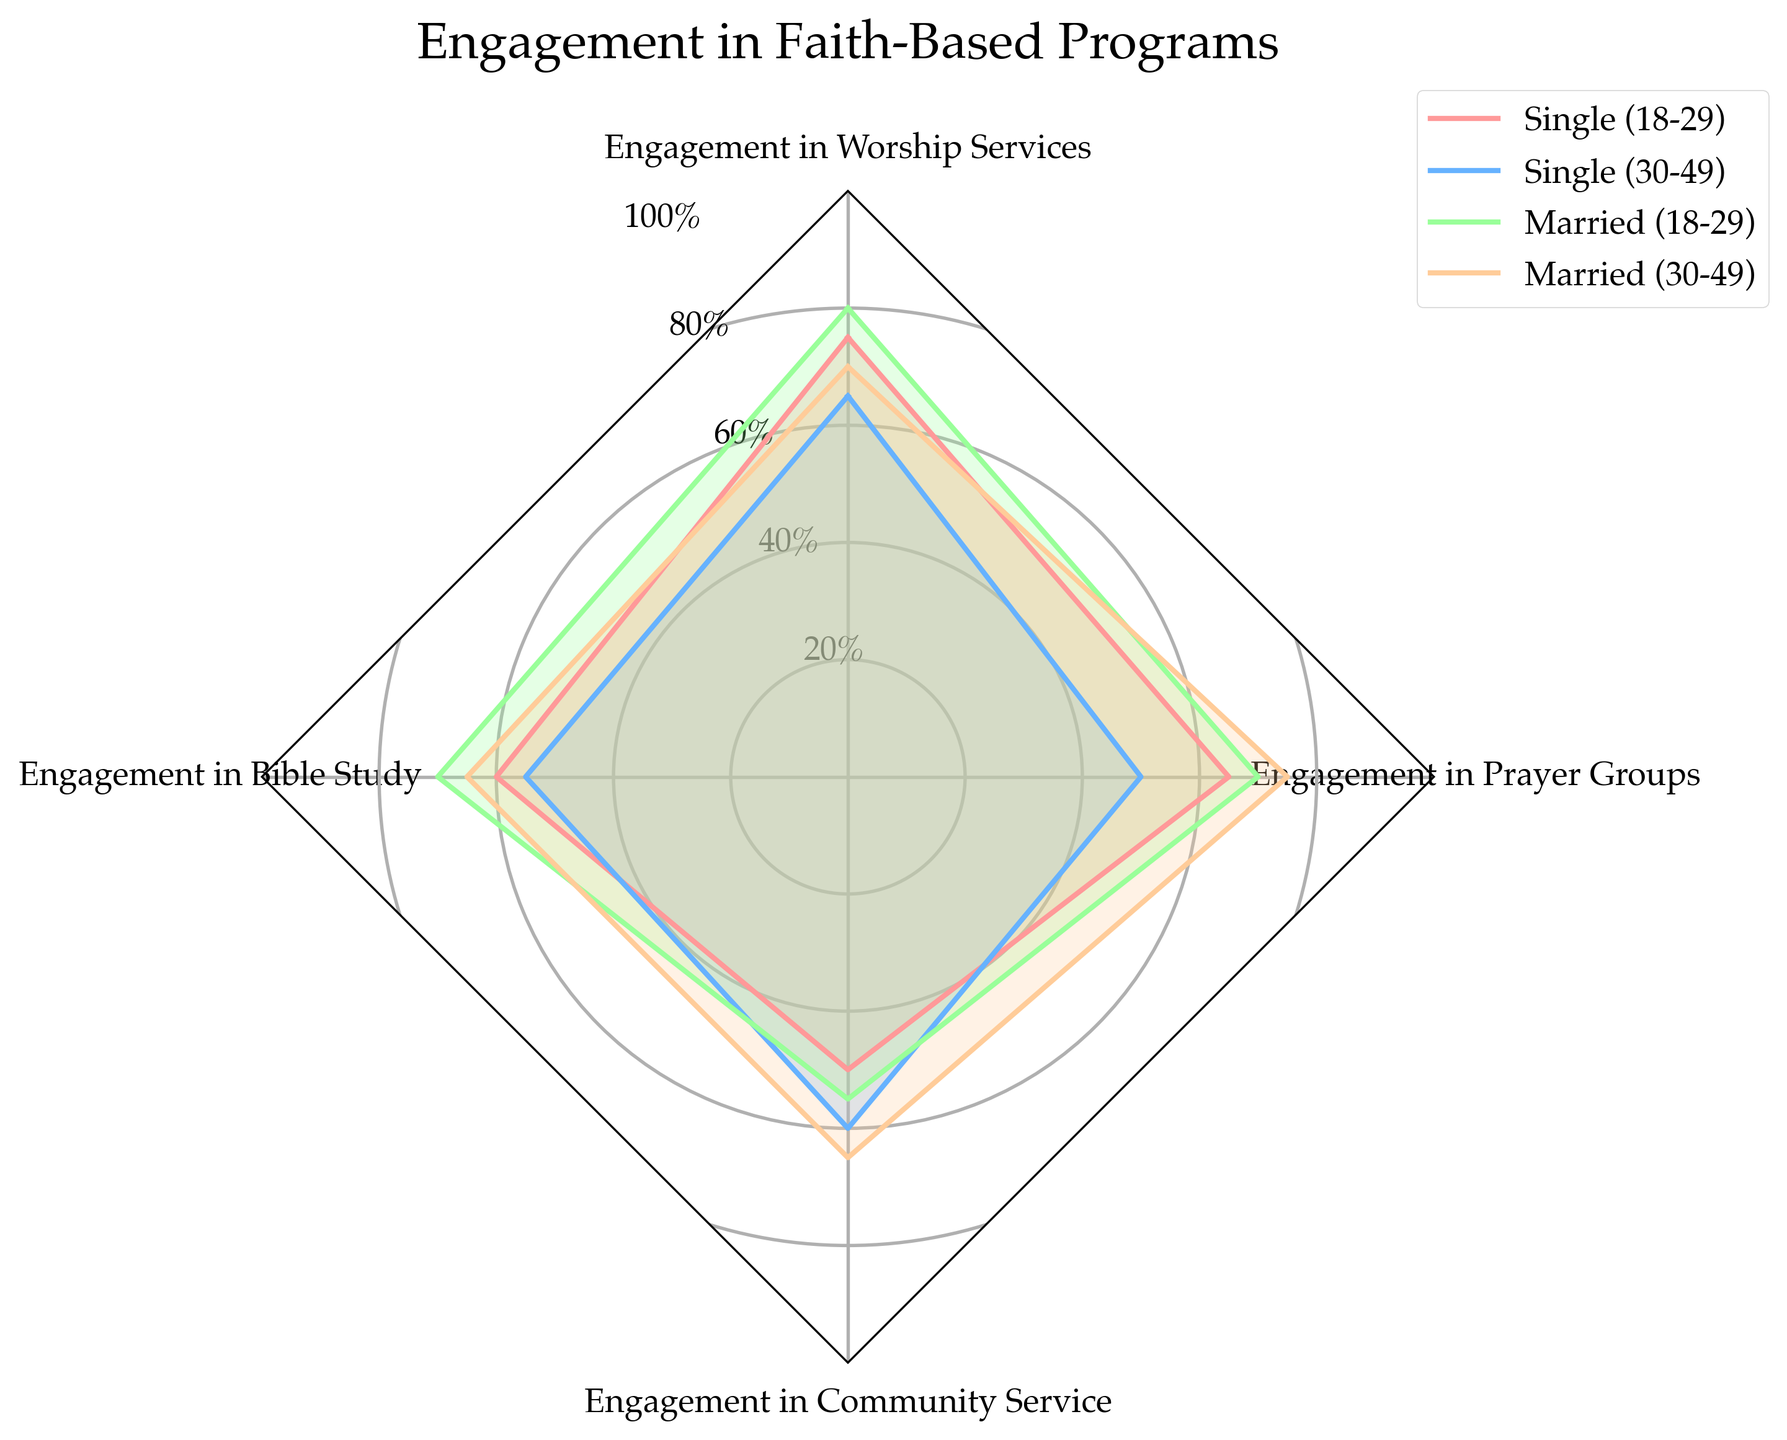What's the total engagement score for Middle-Aged Singles? Sum the engagement values for Middle-Aged Singles: 65 (Worship Services) + 55 (Bible Study) + 60 (Community Service) + 50 (Prayer Groups).
Answer: 230 Which group has the highest engagement in Worship Services? Compare the engagement in Worship Services for all groups: Young Singles (75), Middle-Aged Singles (65), Young Married (80), and Middle-Aged Married (70). The highest value is 80 for Young Married.
Answer: Young Married Which group shows the lowest engagement in Prayer Groups? Compare the engagement in Prayer Groups for all groups: Young Singles (65), Middle-Aged Singles (50), Young Married (70), and Middle-Aged Married (75). The lowest value is 50 for Middle-Aged Singles.
Answer: Middle-Aged Singles What is the difference in engagement in Bible Study between Young Married and Middle-Aged Married individuals? Subtract the engagement in Bible Study for Middle-Aged Married (65) from Young Married (70).
Answer: 5 How does the engagement in Community Service for Young Married compare to Young Singles? Compare the engagement in Community Service for Young Married (55) and Young Singles (50). The Young Married group has a higher value.
Answer: Young Married What is the average engagement across all activities for Young Singles? Calculate the average of Young Singles engagement values: (75 (Worship Services) + 60 (Bible Study) + 50 (Community Service) + 65 (Prayer Groups)) / 4.
Answer: 62.5 Which group has the most balanced engagement across all categories? Identify the group with the smallest variance in engagement values across Worship Services, Bible Study, Community Service, and Prayer Groups. The Middle-Aged Married group (70, 65, 65, 75) has the smallest difference between the highest and lowest values.
Answer: Middle-Aged Married In which activity do all groups have the highest average engagement? Calculate the average engagement for each activity: Worship Services ((75 + 65 + 80 + 70) / 4 = 72.5), Bible Study ((60 + 55 + 70 + 65) / 4 = 62.5), Community Service ((50 + 60 + 55 + 65) / 4 = 57.5), Prayer Groups ((65 + 50 + 70 + 75) / 4 = 65). The highest average is in Worship Services.
Answer: Worship Services 